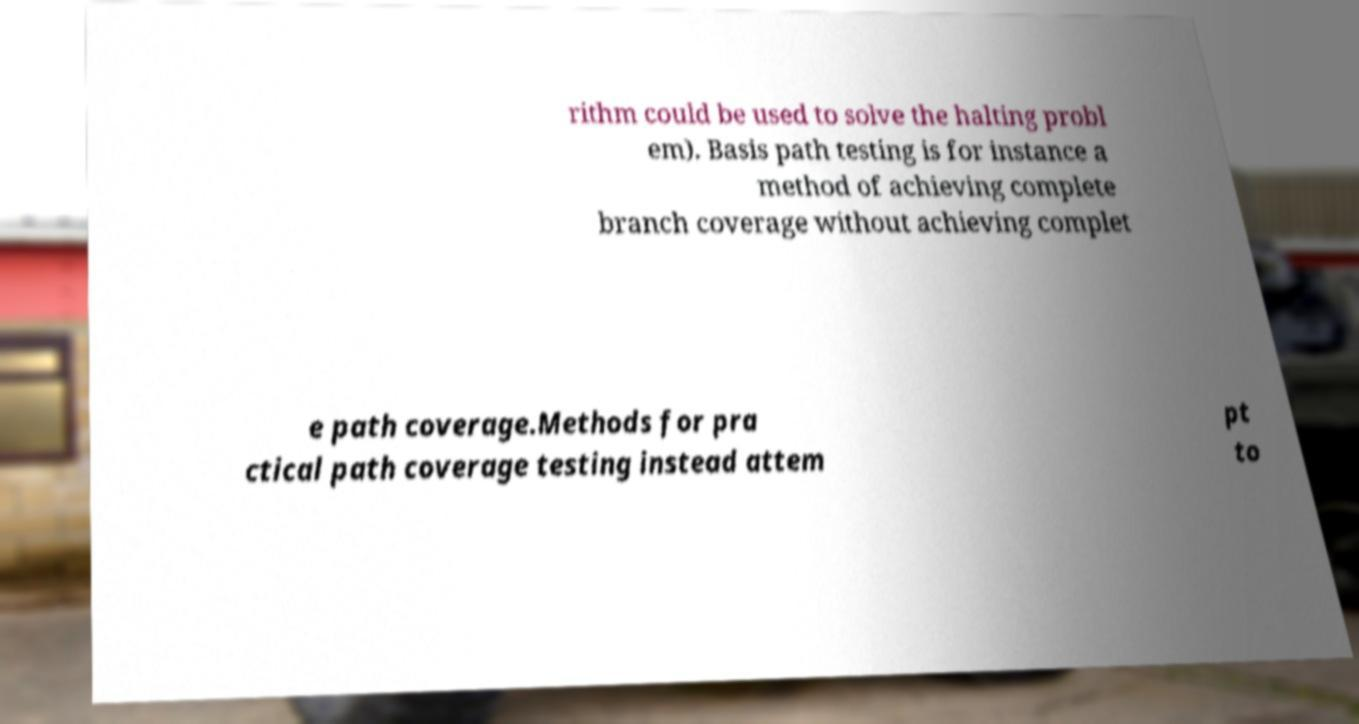For documentation purposes, I need the text within this image transcribed. Could you provide that? rithm could be used to solve the halting probl em). Basis path testing is for instance a method of achieving complete branch coverage without achieving complet e path coverage.Methods for pra ctical path coverage testing instead attem pt to 